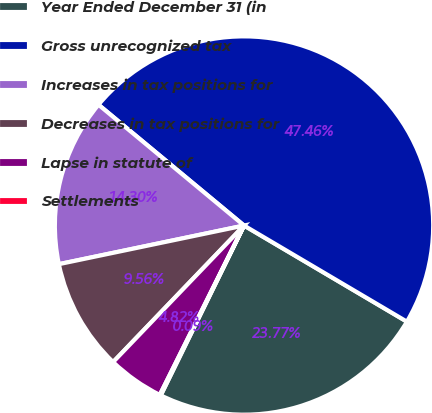<chart> <loc_0><loc_0><loc_500><loc_500><pie_chart><fcel>Year Ended December 31 (in<fcel>Gross unrecognized tax<fcel>Increases in tax positions for<fcel>Decreases in tax positions for<fcel>Lapse in statute of<fcel>Settlements<nl><fcel>23.77%<fcel>47.46%<fcel>14.3%<fcel>9.56%<fcel>4.82%<fcel>0.09%<nl></chart> 